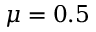<formula> <loc_0><loc_0><loc_500><loc_500>\mu = 0 . 5</formula> 